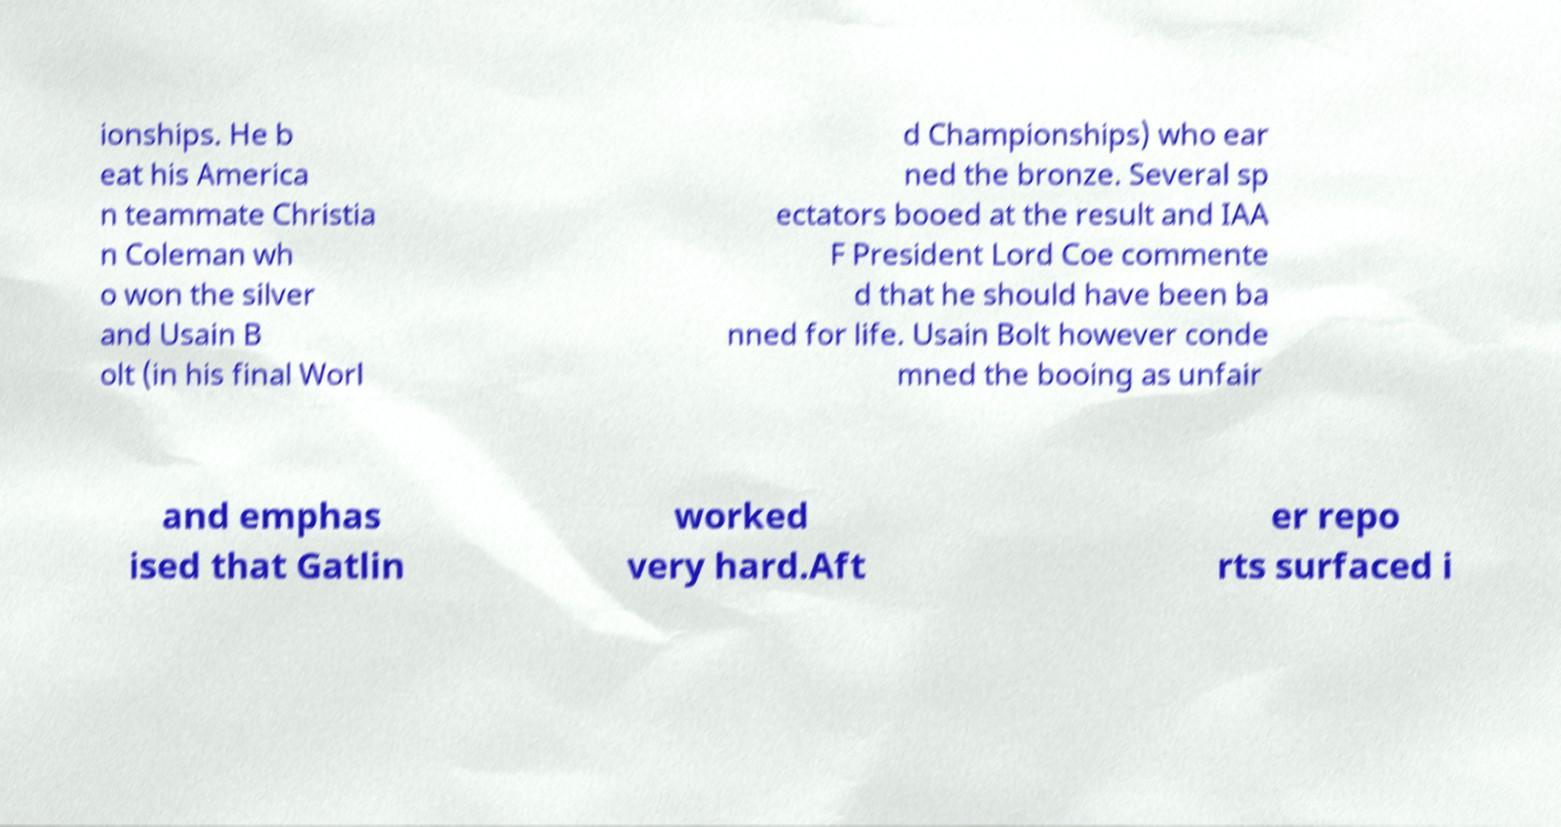What messages or text are displayed in this image? I need them in a readable, typed format. ionships. He b eat his America n teammate Christia n Coleman wh o won the silver and Usain B olt (in his final Worl d Championships) who ear ned the bronze. Several sp ectators booed at the result and IAA F President Lord Coe commente d that he should have been ba nned for life. Usain Bolt however conde mned the booing as unfair and emphas ised that Gatlin worked very hard.Aft er repo rts surfaced i 